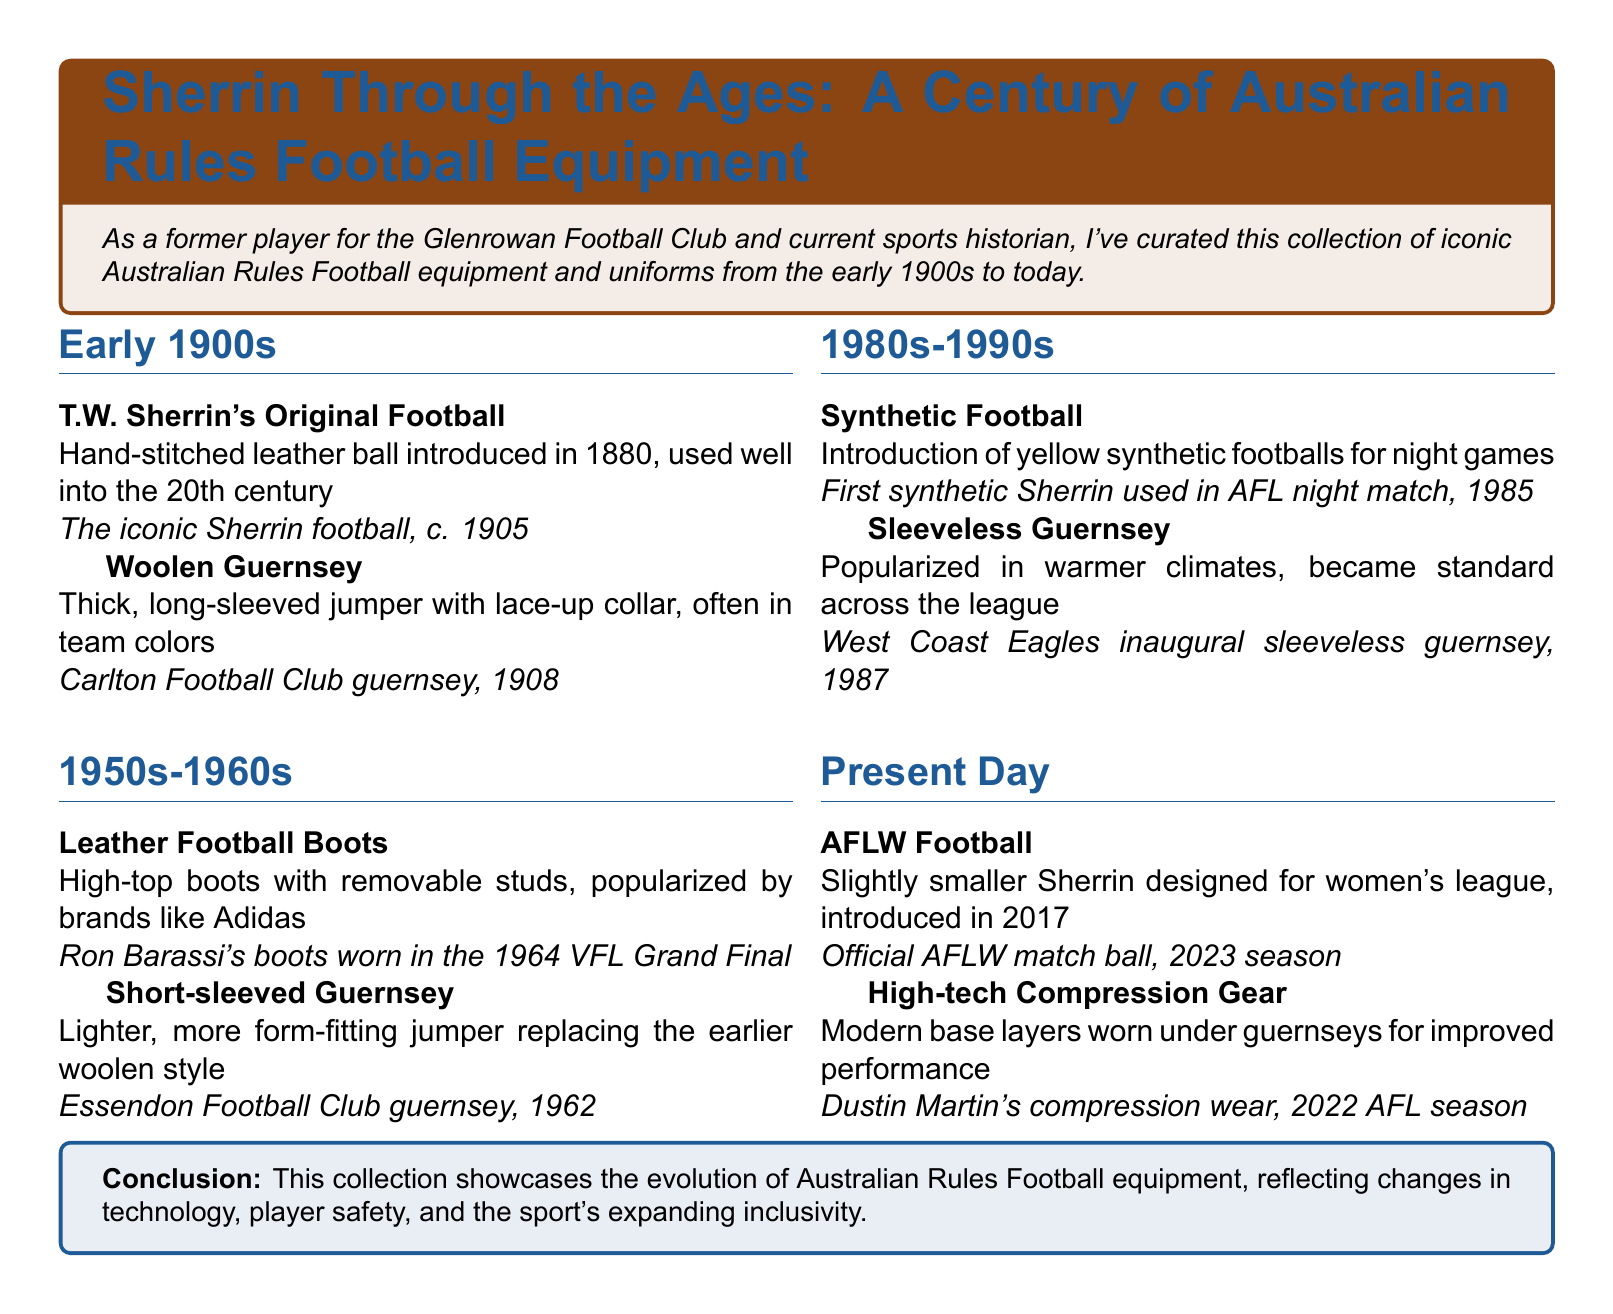what was introduced in 1880? The document states that T.W. Sherrin's Original Football was introduced in 1880.
Answer: T.W. Sherrin's Original Football what type of guernsey was worn by the Carlton Football Club in 1908? The document specifies that the woolen guernsey was utilized by the Carlton Football Club in 1908.
Answer: Woolen Guernsey who wore the boots in the 1964 VFL Grand Final? The document mentions that Ron Barassi wore the leather football boots in the 1964 VFL Grand Final.
Answer: Ron Barassi when was the first synthetic Sherrin used? The document indicates that the first synthetic Sherrin was used in 1985 during an AFL night match.
Answer: 1985 what is the name of the official AFLW match ball? The document identifies the official AFLW match ball as the AFLW Football.
Answer: AFLW Football how has the guernsey style evolved from the early 1900s to present day? The document outlines the transition from woolen guernseys to modern high-tech compression gear, indicating ongoing evolution in design and functionality.
Answer: From woolen to high-tech compression gear what distinguishes the AFLW football from the regular football? The document notes that the AFLW football is slightly smaller than the traditional Sherrin.
Answer: Slightly smaller which football club's guernsey is shown from 1962? According to the document, the short-sleeved guernsey shown from 1962 belongs to Essendon Football Club.
Answer: Essendon Football Club what year marks the introduction of the high-tech compression gear? The document states that the high-tech compression gear was worn in the 2022 AFL season.
Answer: 2022 